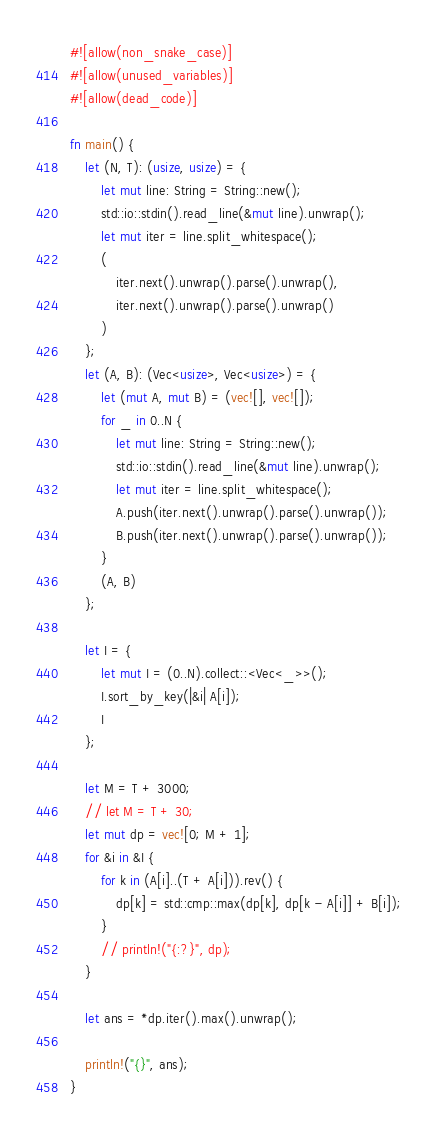<code> <loc_0><loc_0><loc_500><loc_500><_Rust_>#![allow(non_snake_case)]
#![allow(unused_variables)]
#![allow(dead_code)]

fn main() {
    let (N, T): (usize, usize) = {
        let mut line: String = String::new();
        std::io::stdin().read_line(&mut line).unwrap();
        let mut iter = line.split_whitespace();
        (
            iter.next().unwrap().parse().unwrap(),
            iter.next().unwrap().parse().unwrap()
        )
    };
    let (A, B): (Vec<usize>, Vec<usize>) = {
        let (mut A, mut B) = (vec![], vec![]);
        for _ in 0..N {
            let mut line: String = String::new();
            std::io::stdin().read_line(&mut line).unwrap();
            let mut iter = line.split_whitespace();
            A.push(iter.next().unwrap().parse().unwrap());
            B.push(iter.next().unwrap().parse().unwrap());
        }
        (A, B)
    };

    let I = {
        let mut I = (0..N).collect::<Vec<_>>();
        I.sort_by_key(|&i| A[i]);
        I
    };

    let M = T + 3000;
    // let M = T + 30;
    let mut dp = vec![0; M + 1];
    for &i in &I {
        for k in (A[i]..(T + A[i])).rev() {
            dp[k] = std::cmp::max(dp[k], dp[k - A[i]] + B[i]);
        }
        // println!("{:?}", dp);
    }

    let ans = *dp.iter().max().unwrap();

    println!("{}", ans);
}
</code> 